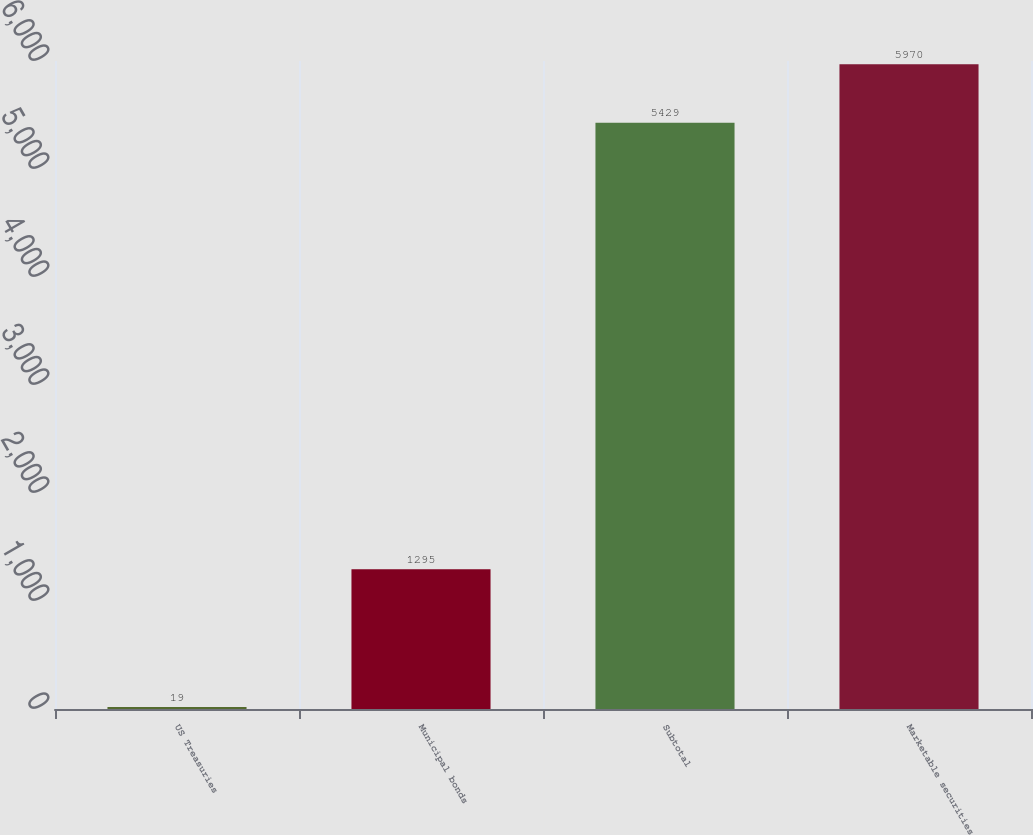Convert chart. <chart><loc_0><loc_0><loc_500><loc_500><bar_chart><fcel>US Treasuries<fcel>Municipal bonds<fcel>Subtotal<fcel>Marketable securities<nl><fcel>19<fcel>1295<fcel>5429<fcel>5970<nl></chart> 